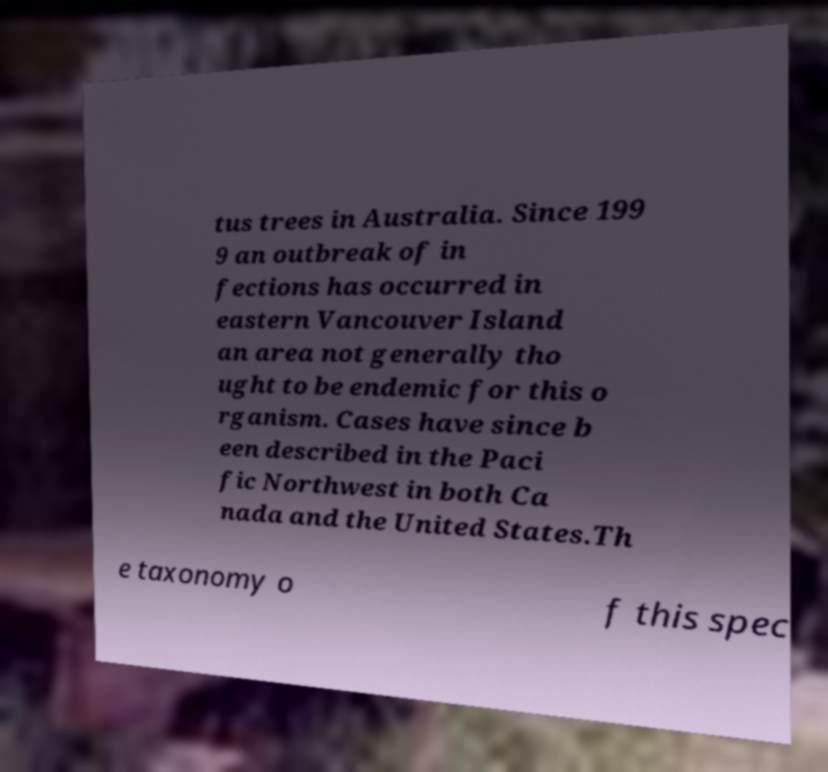Please identify and transcribe the text found in this image. tus trees in Australia. Since 199 9 an outbreak of in fections has occurred in eastern Vancouver Island an area not generally tho ught to be endemic for this o rganism. Cases have since b een described in the Paci fic Northwest in both Ca nada and the United States.Th e taxonomy o f this spec 